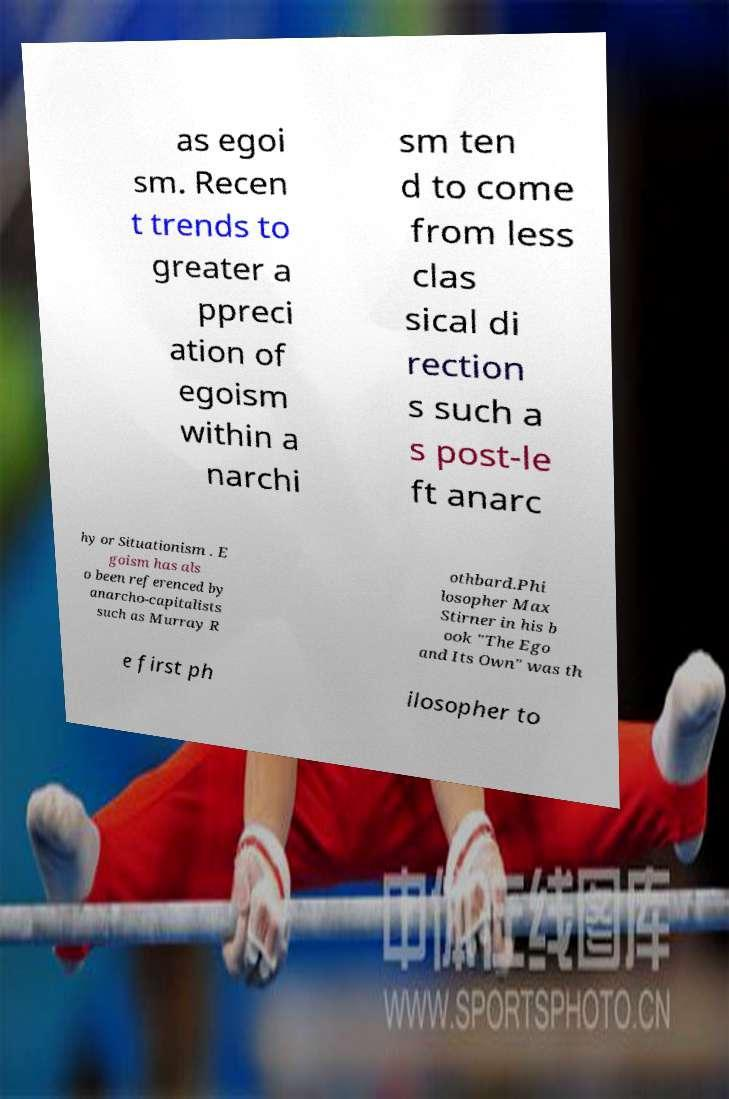Can you read and provide the text displayed in the image?This photo seems to have some interesting text. Can you extract and type it out for me? as egoi sm. Recen t trends to greater a ppreci ation of egoism within a narchi sm ten d to come from less clas sical di rection s such a s post-le ft anarc hy or Situationism . E goism has als o been referenced by anarcho-capitalists such as Murray R othbard.Phi losopher Max Stirner in his b ook "The Ego and Its Own" was th e first ph ilosopher to 